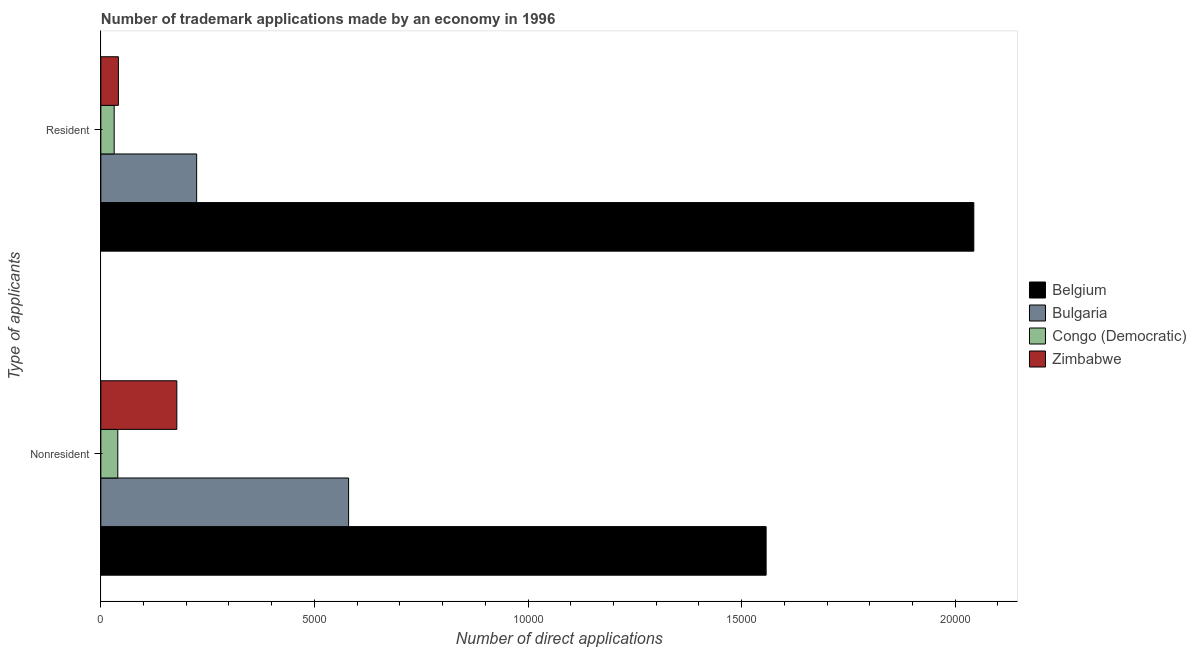Are the number of bars per tick equal to the number of legend labels?
Make the answer very short. Yes. Are the number of bars on each tick of the Y-axis equal?
Your answer should be very brief. Yes. How many bars are there on the 1st tick from the top?
Give a very brief answer. 4. How many bars are there on the 2nd tick from the bottom?
Ensure brevity in your answer.  4. What is the label of the 2nd group of bars from the top?
Your response must be concise. Nonresident. What is the number of trademark applications made by residents in Zimbabwe?
Ensure brevity in your answer.  411. Across all countries, what is the maximum number of trademark applications made by residents?
Your answer should be compact. 2.04e+04. Across all countries, what is the minimum number of trademark applications made by non residents?
Make the answer very short. 397. In which country was the number of trademark applications made by non residents minimum?
Keep it short and to the point. Congo (Democratic). What is the total number of trademark applications made by non residents in the graph?
Keep it short and to the point. 2.36e+04. What is the difference between the number of trademark applications made by residents in Zimbabwe and that in Bulgaria?
Keep it short and to the point. -1832. What is the difference between the number of trademark applications made by residents in Congo (Democratic) and the number of trademark applications made by non residents in Bulgaria?
Offer a very short reply. -5488. What is the average number of trademark applications made by residents per country?
Offer a terse response. 5850.75. What is the difference between the number of trademark applications made by non residents and number of trademark applications made by residents in Congo (Democratic)?
Your answer should be compact. 85. In how many countries, is the number of trademark applications made by residents greater than 10000 ?
Your answer should be very brief. 1. What is the ratio of the number of trademark applications made by residents in Bulgaria to that in Congo (Democratic)?
Your response must be concise. 7.19. In how many countries, is the number of trademark applications made by residents greater than the average number of trademark applications made by residents taken over all countries?
Offer a very short reply. 1. What does the 3rd bar from the top in Nonresident represents?
Keep it short and to the point. Bulgaria. What is the difference between two consecutive major ticks on the X-axis?
Provide a short and direct response. 5000. How are the legend labels stacked?
Give a very brief answer. Vertical. What is the title of the graph?
Make the answer very short. Number of trademark applications made by an economy in 1996. What is the label or title of the X-axis?
Your answer should be compact. Number of direct applications. What is the label or title of the Y-axis?
Provide a short and direct response. Type of applicants. What is the Number of direct applications in Belgium in Nonresident?
Give a very brief answer. 1.56e+04. What is the Number of direct applications in Bulgaria in Nonresident?
Keep it short and to the point. 5800. What is the Number of direct applications of Congo (Democratic) in Nonresident?
Provide a succinct answer. 397. What is the Number of direct applications of Zimbabwe in Nonresident?
Make the answer very short. 1779. What is the Number of direct applications of Belgium in Resident?
Make the answer very short. 2.04e+04. What is the Number of direct applications in Bulgaria in Resident?
Provide a succinct answer. 2243. What is the Number of direct applications of Congo (Democratic) in Resident?
Your response must be concise. 312. What is the Number of direct applications in Zimbabwe in Resident?
Your answer should be very brief. 411. Across all Type of applicants, what is the maximum Number of direct applications in Belgium?
Your response must be concise. 2.04e+04. Across all Type of applicants, what is the maximum Number of direct applications in Bulgaria?
Make the answer very short. 5800. Across all Type of applicants, what is the maximum Number of direct applications in Congo (Democratic)?
Your answer should be compact. 397. Across all Type of applicants, what is the maximum Number of direct applications of Zimbabwe?
Provide a succinct answer. 1779. Across all Type of applicants, what is the minimum Number of direct applications in Belgium?
Provide a short and direct response. 1.56e+04. Across all Type of applicants, what is the minimum Number of direct applications in Bulgaria?
Make the answer very short. 2243. Across all Type of applicants, what is the minimum Number of direct applications in Congo (Democratic)?
Your answer should be compact. 312. Across all Type of applicants, what is the minimum Number of direct applications in Zimbabwe?
Give a very brief answer. 411. What is the total Number of direct applications of Belgium in the graph?
Give a very brief answer. 3.60e+04. What is the total Number of direct applications of Bulgaria in the graph?
Your response must be concise. 8043. What is the total Number of direct applications of Congo (Democratic) in the graph?
Your response must be concise. 709. What is the total Number of direct applications in Zimbabwe in the graph?
Offer a very short reply. 2190. What is the difference between the Number of direct applications of Belgium in Nonresident and that in Resident?
Provide a short and direct response. -4862. What is the difference between the Number of direct applications of Bulgaria in Nonresident and that in Resident?
Make the answer very short. 3557. What is the difference between the Number of direct applications of Zimbabwe in Nonresident and that in Resident?
Offer a very short reply. 1368. What is the difference between the Number of direct applications in Belgium in Nonresident and the Number of direct applications in Bulgaria in Resident?
Offer a very short reply. 1.33e+04. What is the difference between the Number of direct applications of Belgium in Nonresident and the Number of direct applications of Congo (Democratic) in Resident?
Your answer should be very brief. 1.53e+04. What is the difference between the Number of direct applications of Belgium in Nonresident and the Number of direct applications of Zimbabwe in Resident?
Ensure brevity in your answer.  1.52e+04. What is the difference between the Number of direct applications of Bulgaria in Nonresident and the Number of direct applications of Congo (Democratic) in Resident?
Provide a short and direct response. 5488. What is the difference between the Number of direct applications in Bulgaria in Nonresident and the Number of direct applications in Zimbabwe in Resident?
Provide a short and direct response. 5389. What is the difference between the Number of direct applications of Congo (Democratic) in Nonresident and the Number of direct applications of Zimbabwe in Resident?
Keep it short and to the point. -14. What is the average Number of direct applications of Belgium per Type of applicants?
Your response must be concise. 1.80e+04. What is the average Number of direct applications in Bulgaria per Type of applicants?
Provide a succinct answer. 4021.5. What is the average Number of direct applications of Congo (Democratic) per Type of applicants?
Provide a succinct answer. 354.5. What is the average Number of direct applications of Zimbabwe per Type of applicants?
Offer a very short reply. 1095. What is the difference between the Number of direct applications in Belgium and Number of direct applications in Bulgaria in Nonresident?
Ensure brevity in your answer.  9775. What is the difference between the Number of direct applications of Belgium and Number of direct applications of Congo (Democratic) in Nonresident?
Ensure brevity in your answer.  1.52e+04. What is the difference between the Number of direct applications in Belgium and Number of direct applications in Zimbabwe in Nonresident?
Keep it short and to the point. 1.38e+04. What is the difference between the Number of direct applications of Bulgaria and Number of direct applications of Congo (Democratic) in Nonresident?
Make the answer very short. 5403. What is the difference between the Number of direct applications of Bulgaria and Number of direct applications of Zimbabwe in Nonresident?
Your answer should be compact. 4021. What is the difference between the Number of direct applications of Congo (Democratic) and Number of direct applications of Zimbabwe in Nonresident?
Your answer should be very brief. -1382. What is the difference between the Number of direct applications of Belgium and Number of direct applications of Bulgaria in Resident?
Your answer should be compact. 1.82e+04. What is the difference between the Number of direct applications of Belgium and Number of direct applications of Congo (Democratic) in Resident?
Provide a short and direct response. 2.01e+04. What is the difference between the Number of direct applications in Belgium and Number of direct applications in Zimbabwe in Resident?
Provide a short and direct response. 2.00e+04. What is the difference between the Number of direct applications of Bulgaria and Number of direct applications of Congo (Democratic) in Resident?
Your answer should be very brief. 1931. What is the difference between the Number of direct applications of Bulgaria and Number of direct applications of Zimbabwe in Resident?
Your answer should be very brief. 1832. What is the difference between the Number of direct applications of Congo (Democratic) and Number of direct applications of Zimbabwe in Resident?
Your response must be concise. -99. What is the ratio of the Number of direct applications of Belgium in Nonresident to that in Resident?
Your answer should be very brief. 0.76. What is the ratio of the Number of direct applications of Bulgaria in Nonresident to that in Resident?
Your answer should be very brief. 2.59. What is the ratio of the Number of direct applications in Congo (Democratic) in Nonresident to that in Resident?
Your answer should be very brief. 1.27. What is the ratio of the Number of direct applications of Zimbabwe in Nonresident to that in Resident?
Give a very brief answer. 4.33. What is the difference between the highest and the second highest Number of direct applications in Belgium?
Give a very brief answer. 4862. What is the difference between the highest and the second highest Number of direct applications in Bulgaria?
Your response must be concise. 3557. What is the difference between the highest and the second highest Number of direct applications in Congo (Democratic)?
Ensure brevity in your answer.  85. What is the difference between the highest and the second highest Number of direct applications in Zimbabwe?
Your answer should be compact. 1368. What is the difference between the highest and the lowest Number of direct applications in Belgium?
Make the answer very short. 4862. What is the difference between the highest and the lowest Number of direct applications in Bulgaria?
Provide a short and direct response. 3557. What is the difference between the highest and the lowest Number of direct applications of Congo (Democratic)?
Give a very brief answer. 85. What is the difference between the highest and the lowest Number of direct applications of Zimbabwe?
Offer a terse response. 1368. 